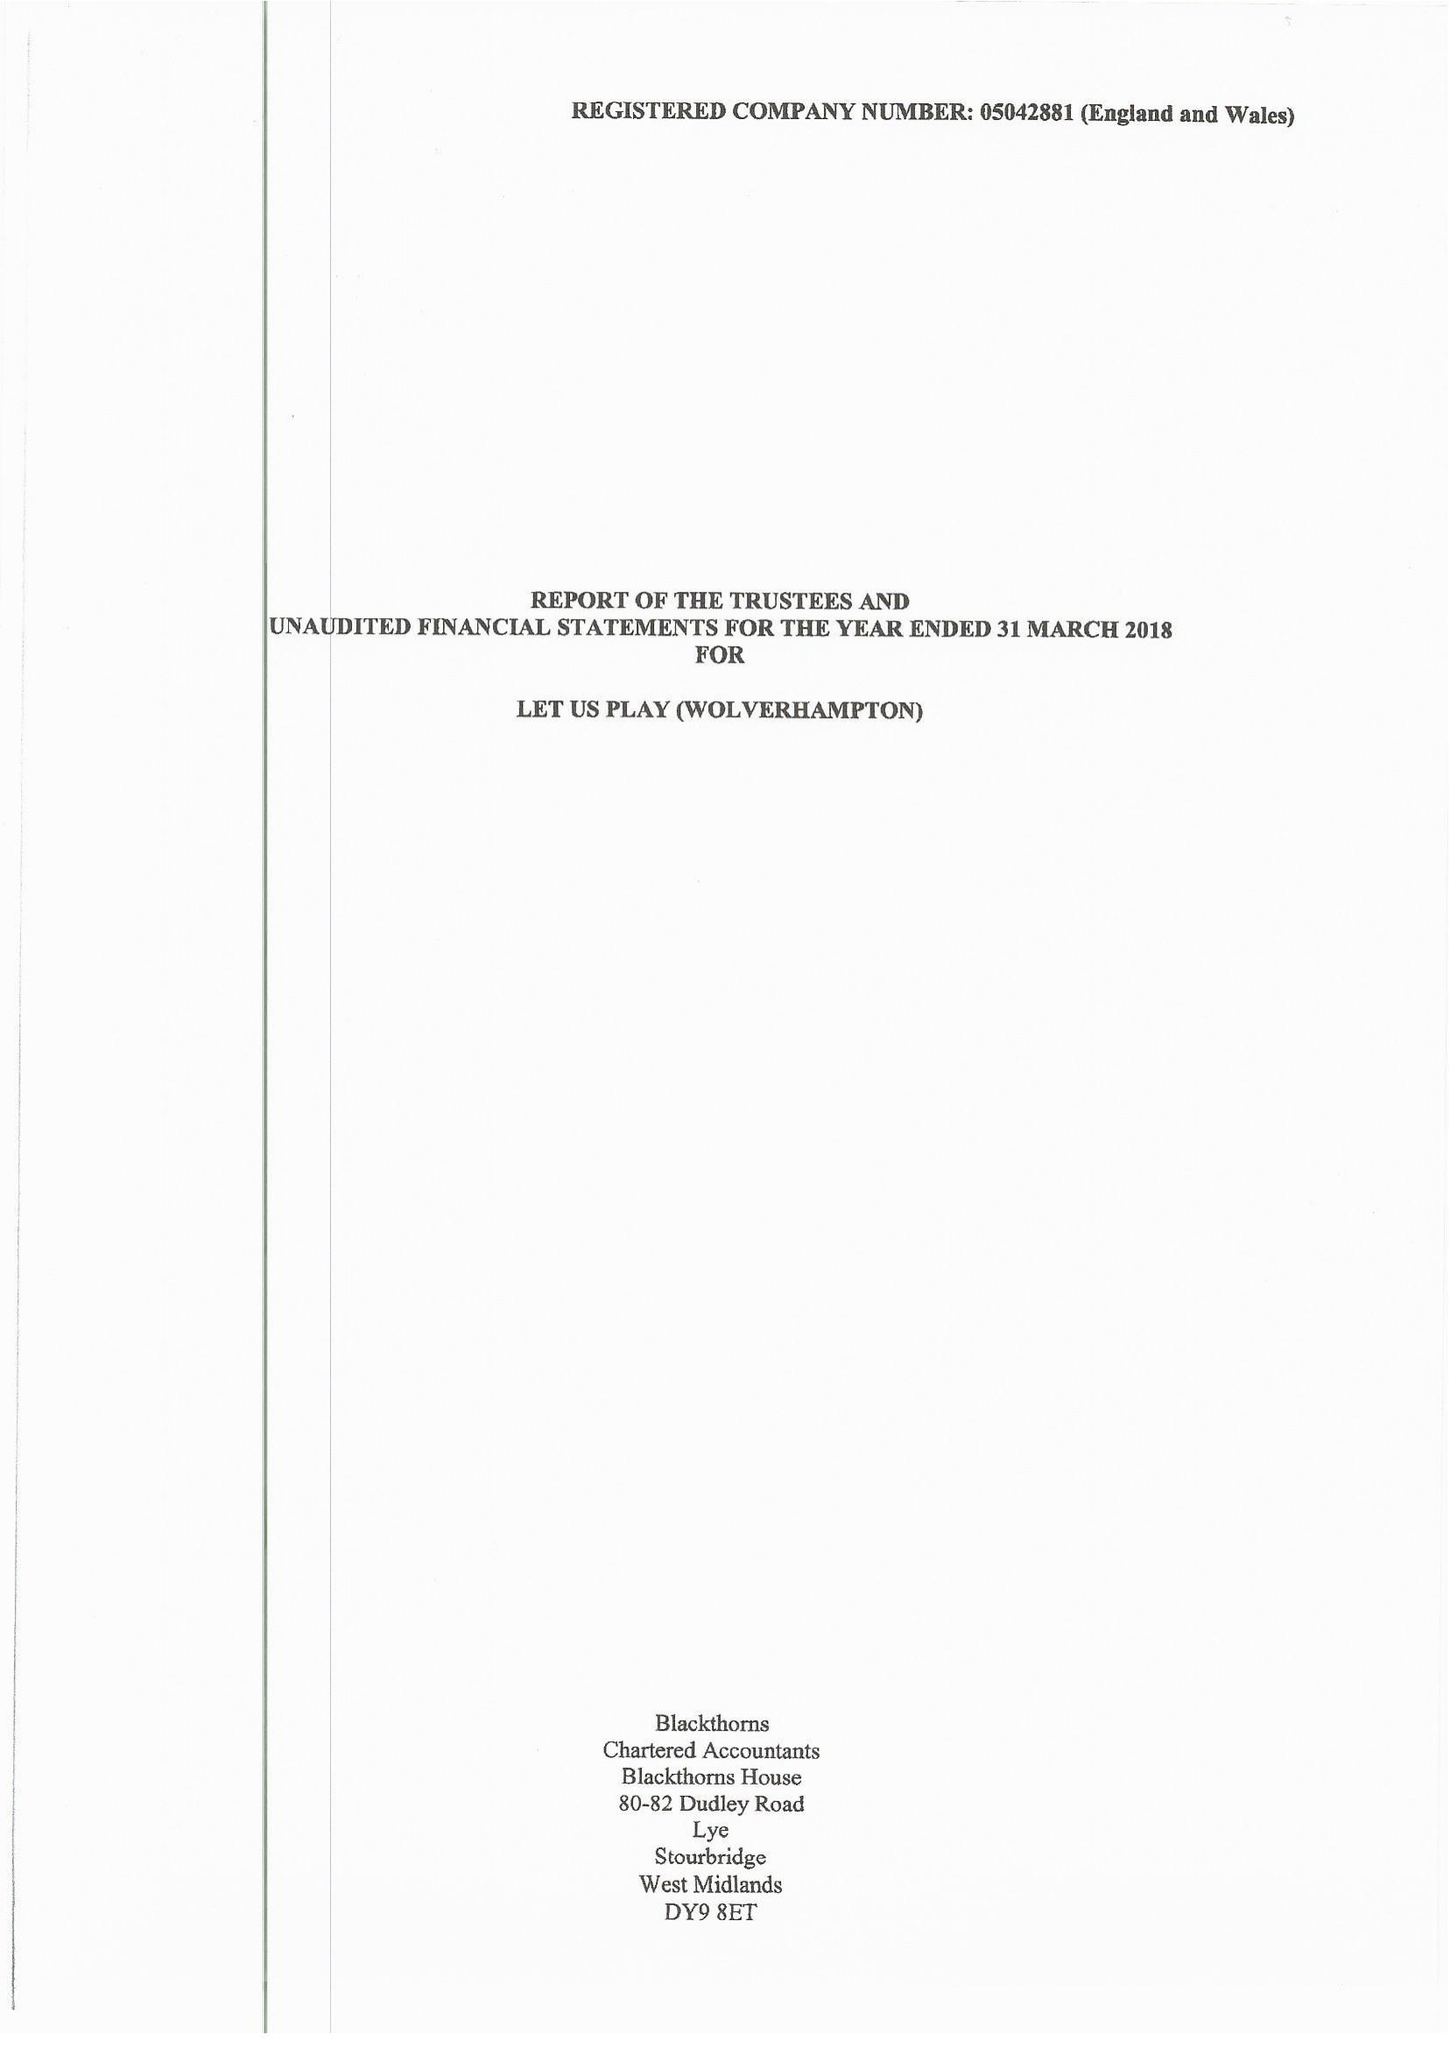What is the value for the charity_name?
Answer the question using a single word or phrase. Let Us Play (Wolverhampton) 